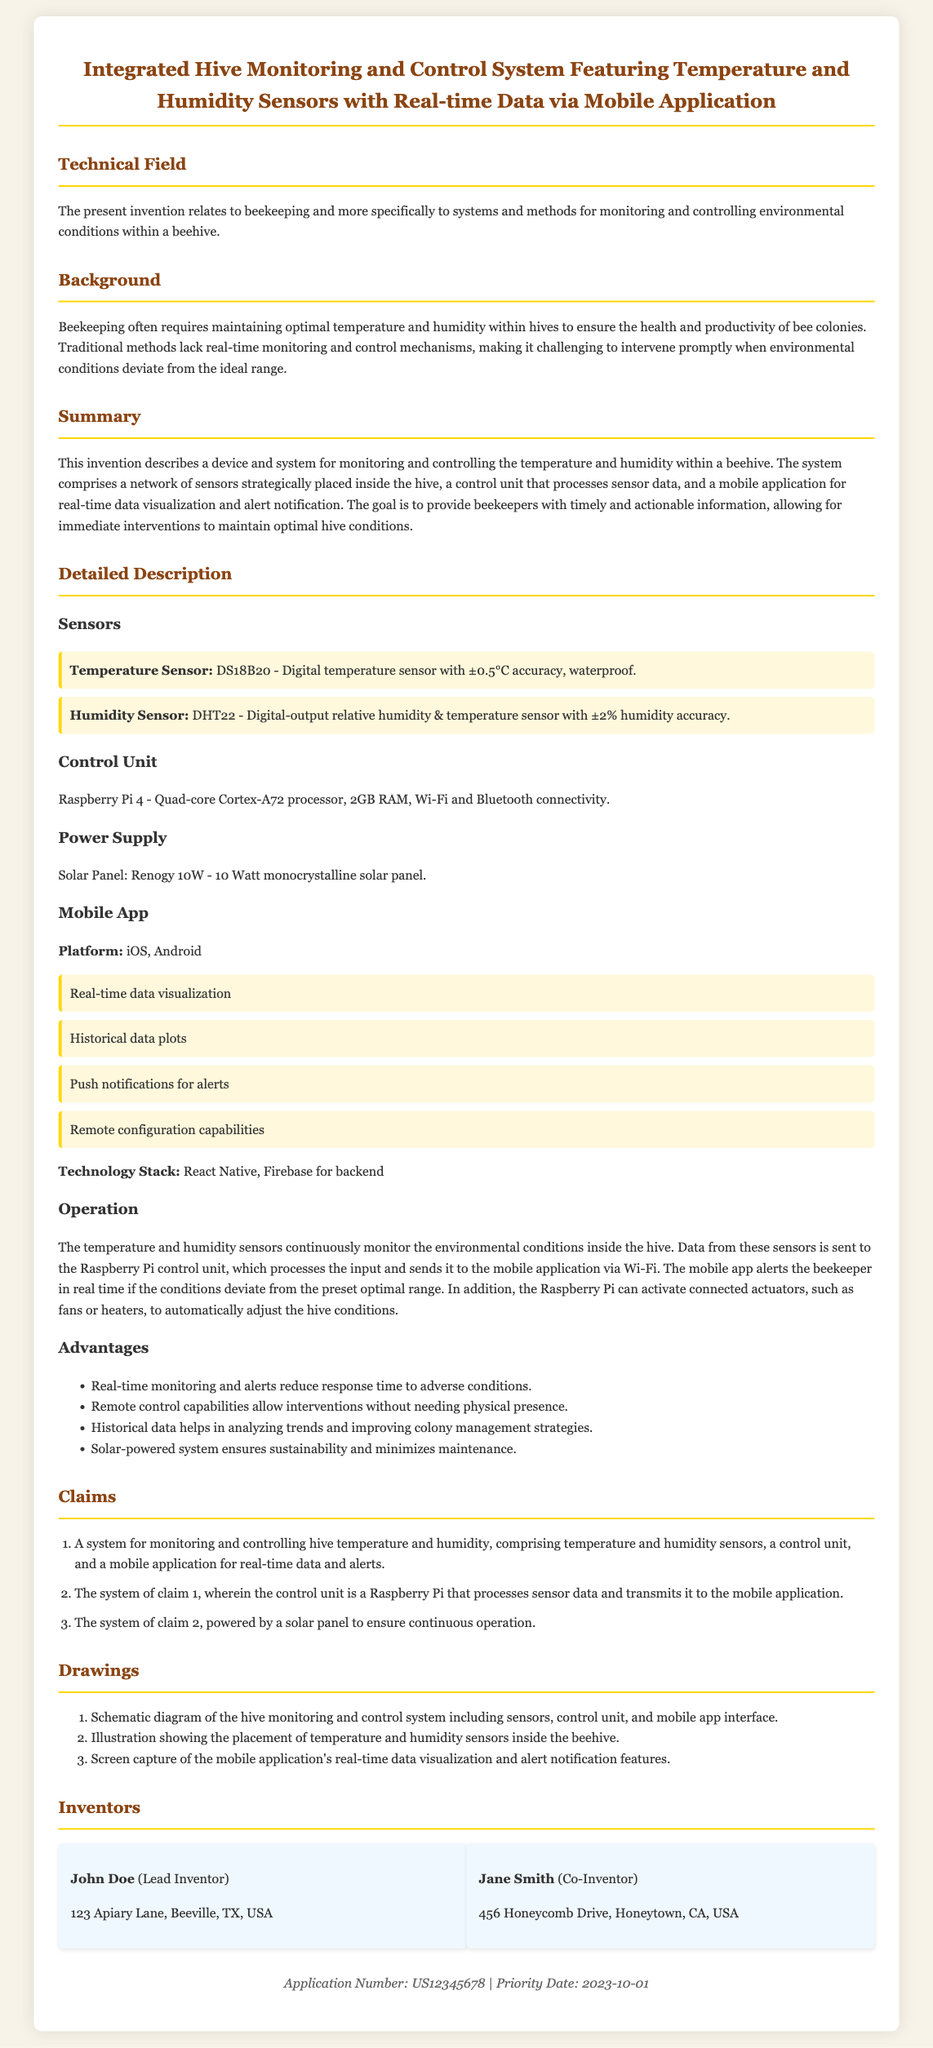What is the title of the patent application? The title provides a brief description of the device and its functionalities as stated in the document.
Answer: Integrated Hive Monitoring and Control System Featuring Temperature and Humidity Sensors with Real-time Data via Mobile Application Who are the inventors of the patent? The inventors are listed in the document under the "Inventors" section with their names and addresses.
Answer: John Doe, Jane Smith What type of sensors are used in the system? The document specifies the types of sensors used in the monitoring system inside the hive.
Answer: Temperature Sensor, Humidity Sensor What is the accuracy of the temperature sensor? The document presents specific information about the temperature sensor's accuracy in the detailed description section.
Answer: ±0.5°C What is the power supply for the system? The document provides details about how the system is powered, particularly the energy source used.
Answer: Solar Panel: Renogy 10W What are the platforms available for the mobile application? The document lists the operating systems that support the mobile application.
Answer: iOS, Android What is the main advantage of real-time monitoring according to the document? This advantage is highlighted in the section discussing the benefits of the monitoring system.
Answer: Reduce response time to adverse conditions How many claims are presented in the patent application? The claims section outlines the specific elements and functionalities claimed in the patent.
Answer: Three claims Which processor is used in the control unit? The document names the processor in the context of the control unit's specifications.
Answer: Quad-core Cortex-A72 processor 